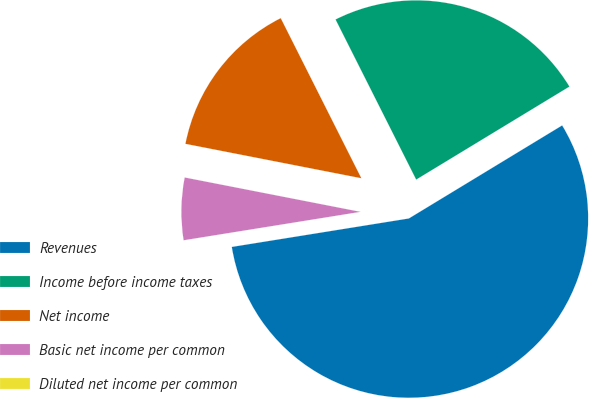Convert chart to OTSL. <chart><loc_0><loc_0><loc_500><loc_500><pie_chart><fcel>Revenues<fcel>Income before income taxes<fcel>Net income<fcel>Basic net income per common<fcel>Diluted net income per common<nl><fcel>56.14%<fcel>23.74%<fcel>14.5%<fcel>5.61%<fcel>0.0%<nl></chart> 